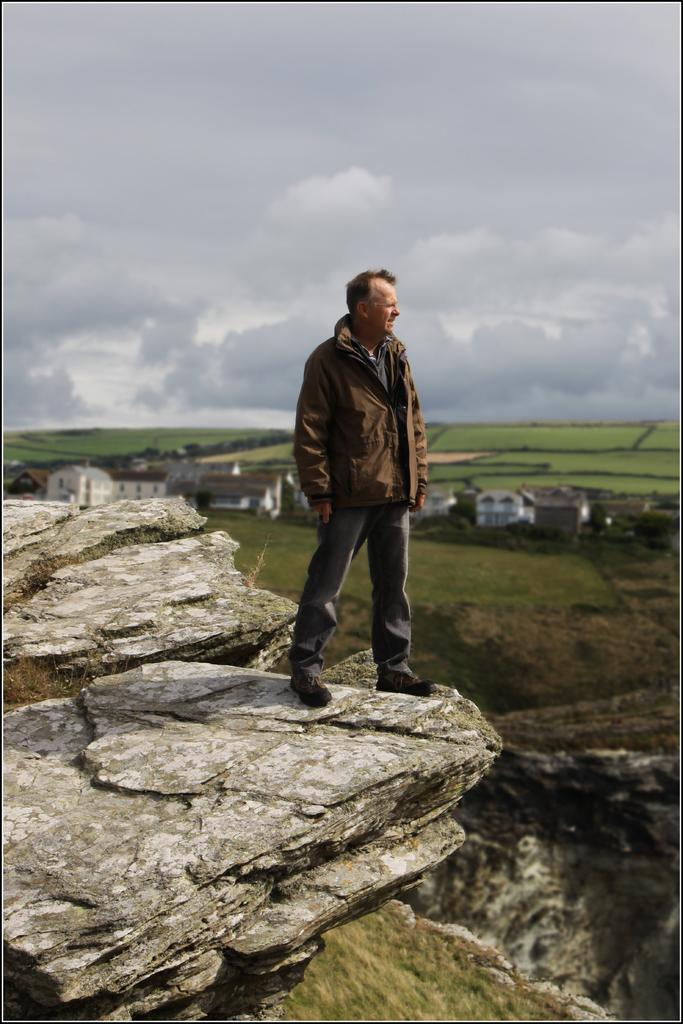What is the person in the image wearing? The person is wearing a jacket in the image. Where is the person standing? The person is standing on a rock in the image. What can be seen in the background of the image? There is a tree and buildings in the background of the image. What is visible in the sky in the image? The sky is visible in the image, and there are clouds in the sky. What type of comb is the person using to groom the beetle in the image? There is no comb or beetle present in the image. 